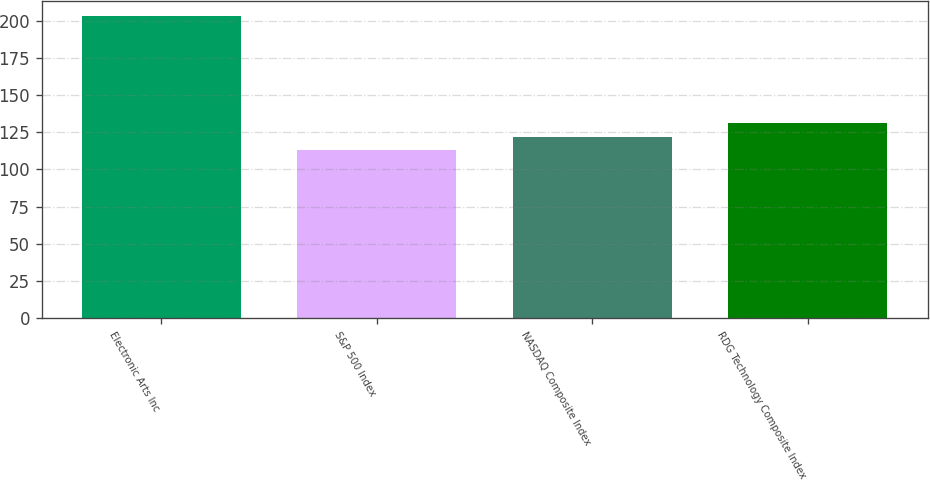Convert chart. <chart><loc_0><loc_0><loc_500><loc_500><bar_chart><fcel>Electronic Arts Inc<fcel>S&P 500 Index<fcel>NASDAQ Composite Index<fcel>RDG Technology Composite Index<nl><fcel>203<fcel>113<fcel>122<fcel>131<nl></chart> 